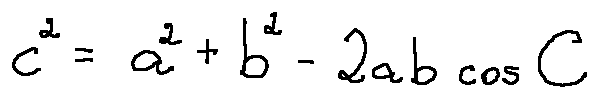Convert formula to latex. <formula><loc_0><loc_0><loc_500><loc_500>c ^ { 2 } = a ^ { 2 } + b ^ { 2 } - 2 a b \cos C</formula> 